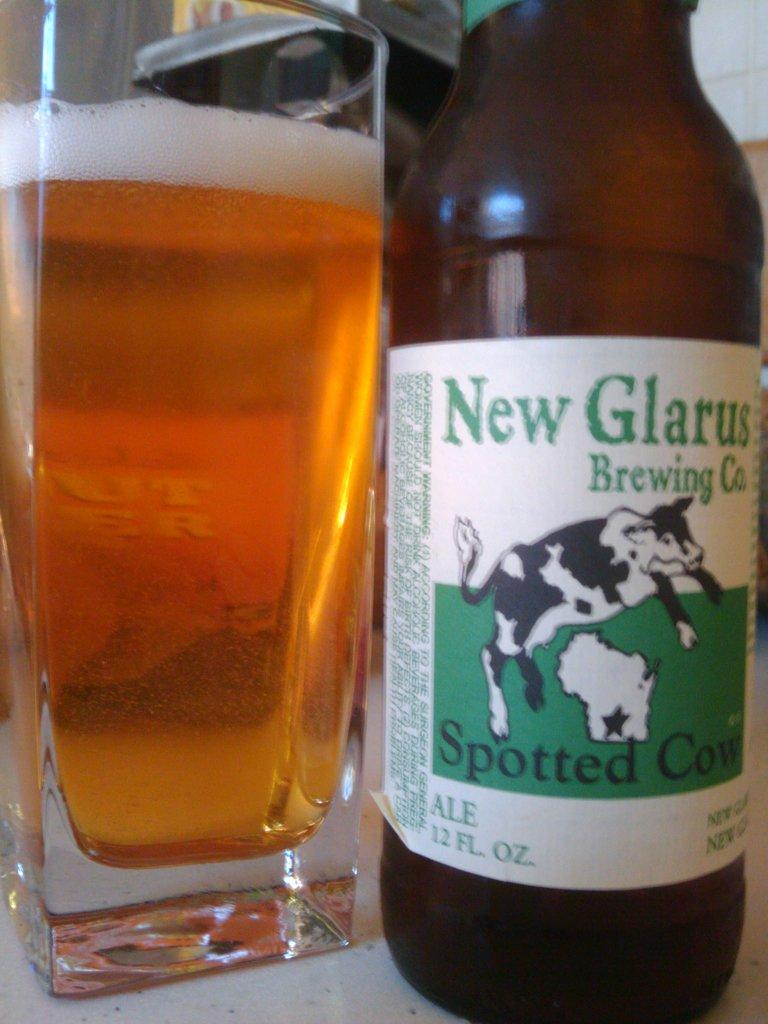Provide a one-sentence caption for the provided image. A cow covered with spots is depicted on the label of a bottle of Spotted Cow beer. 